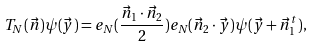<formula> <loc_0><loc_0><loc_500><loc_500>T _ { N } ( \vec { n } ) \psi ( \vec { y } ) = e _ { N } ( \frac { \vec { n } _ { 1 } \cdot \vec { n } _ { 2 } } { 2 } ) e _ { N } ( \vec { n } _ { 2 } \cdot \vec { y } ) \psi ( \vec { y } + \vec { n } _ { 1 } ^ { t } ) ,</formula> 